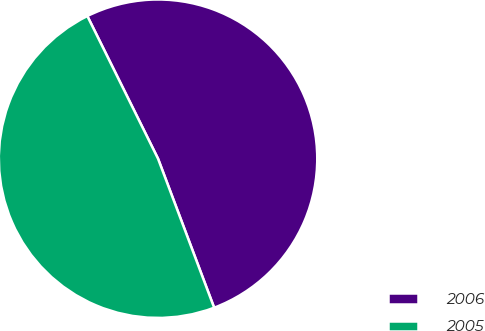Convert chart to OTSL. <chart><loc_0><loc_0><loc_500><loc_500><pie_chart><fcel>2006<fcel>2005<nl><fcel>51.59%<fcel>48.41%<nl></chart> 